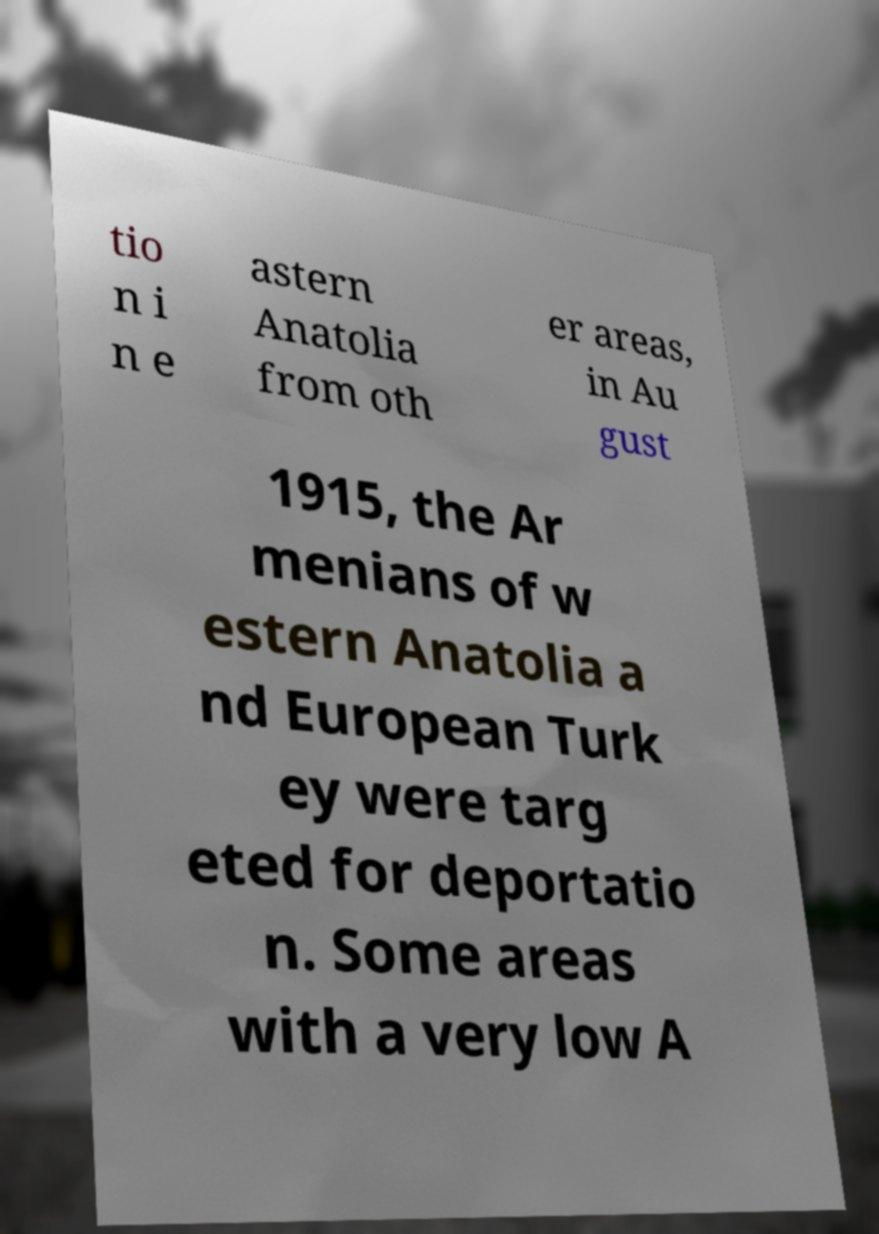Can you read and provide the text displayed in the image?This photo seems to have some interesting text. Can you extract and type it out for me? tio n i n e astern Anatolia from oth er areas, in Au gust 1915, the Ar menians of w estern Anatolia a nd European Turk ey were targ eted for deportatio n. Some areas with a very low A 